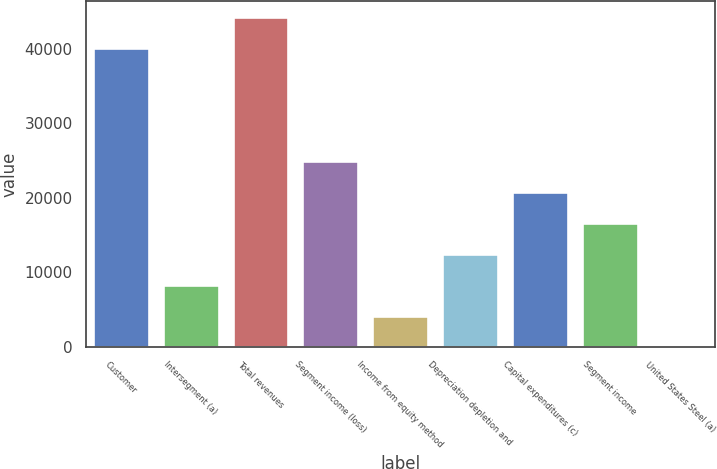Convert chart to OTSL. <chart><loc_0><loc_0><loc_500><loc_500><bar_chart><fcel>Customer<fcel>Intersegment (a)<fcel>Total revenues<fcel>Segment income (loss)<fcel>Income from equity method<fcel>Depreciation depletion and<fcel>Capital expenditures (c)<fcel>Segment income<fcel>United States Steel (a)<nl><fcel>40042<fcel>8338.6<fcel>44196.3<fcel>24955.8<fcel>4184.3<fcel>12492.9<fcel>20801.5<fcel>16647.2<fcel>30<nl></chart> 